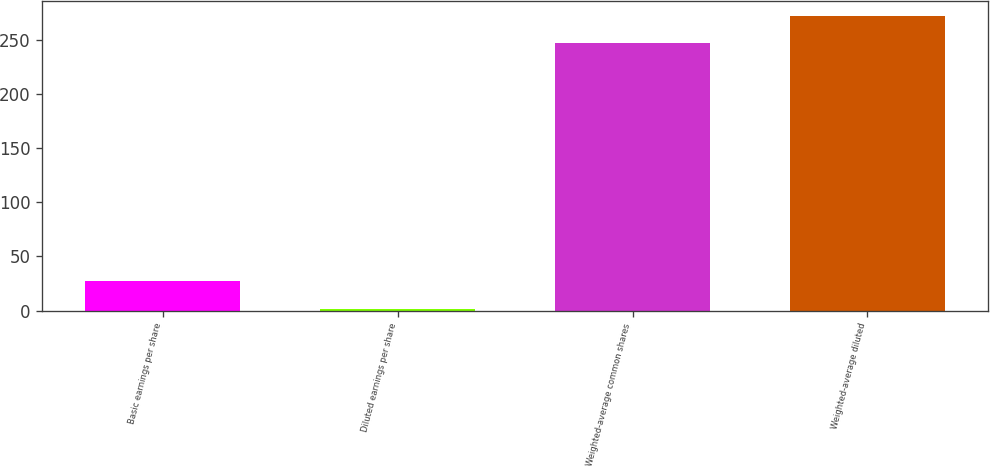Convert chart. <chart><loc_0><loc_0><loc_500><loc_500><bar_chart><fcel>Basic earnings per share<fcel>Diluted earnings per share<fcel>Weighted-average common shares<fcel>Weighted-average diluted<nl><fcel>26.85<fcel>1.82<fcel>247.2<fcel>272.23<nl></chart> 